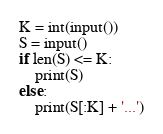<code> <loc_0><loc_0><loc_500><loc_500><_Python_>K = int(input())
S = input()
if len(S) <= K:
    print(S)
else:
    print(S[:K] + '...')</code> 